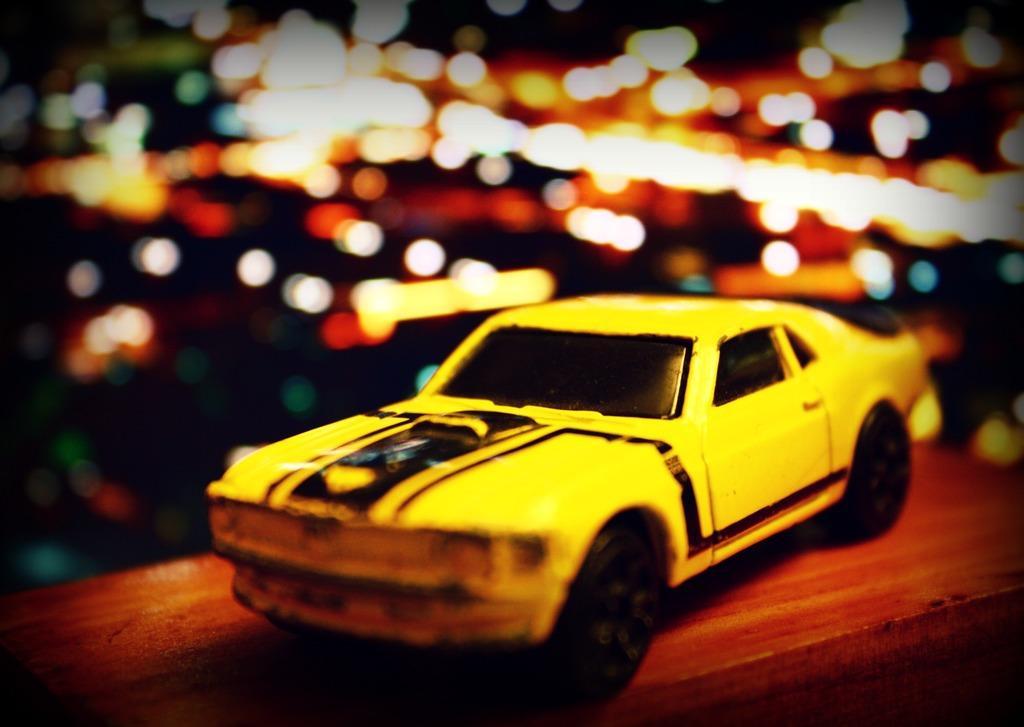Describe this image in one or two sentences. In this picture we can see a toy car in the front, there is a blurry background. 